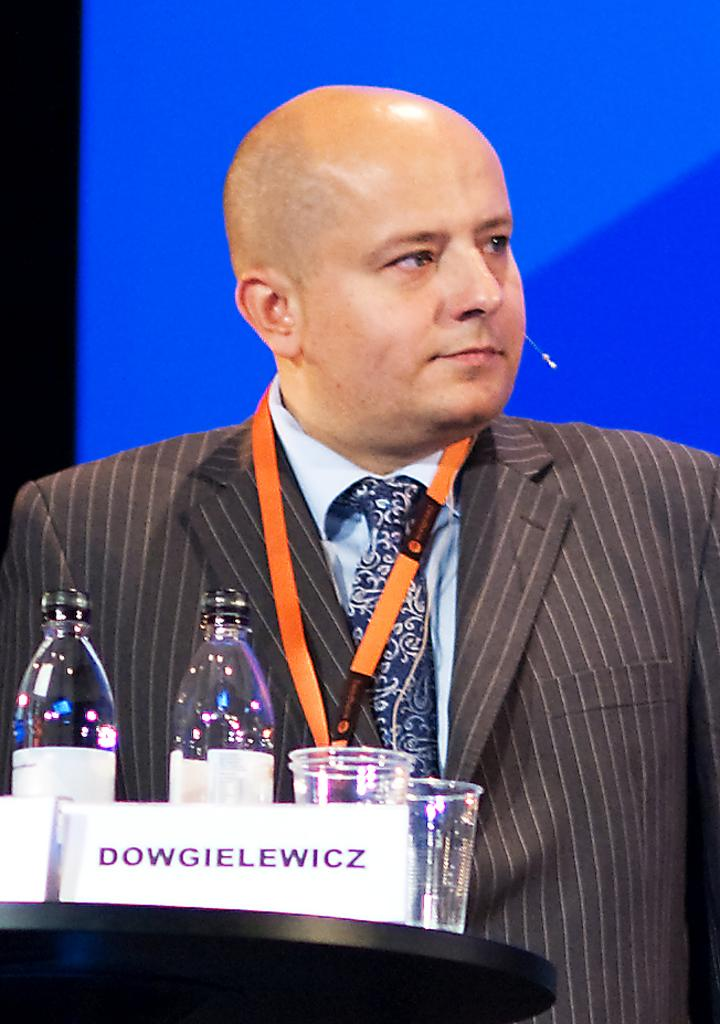Who is present in the image? There is a man in the image. What is the man wearing? The man is wearing a black suit. What objects can be seen in the image besides the man? There are bottles and glasses in the image. Can you see any volcanoes erupting in the image? There are no volcanoes present in the image. What type of teeth does the man have in the image? The image does not show the man's teeth, so it cannot be determined from the image. 